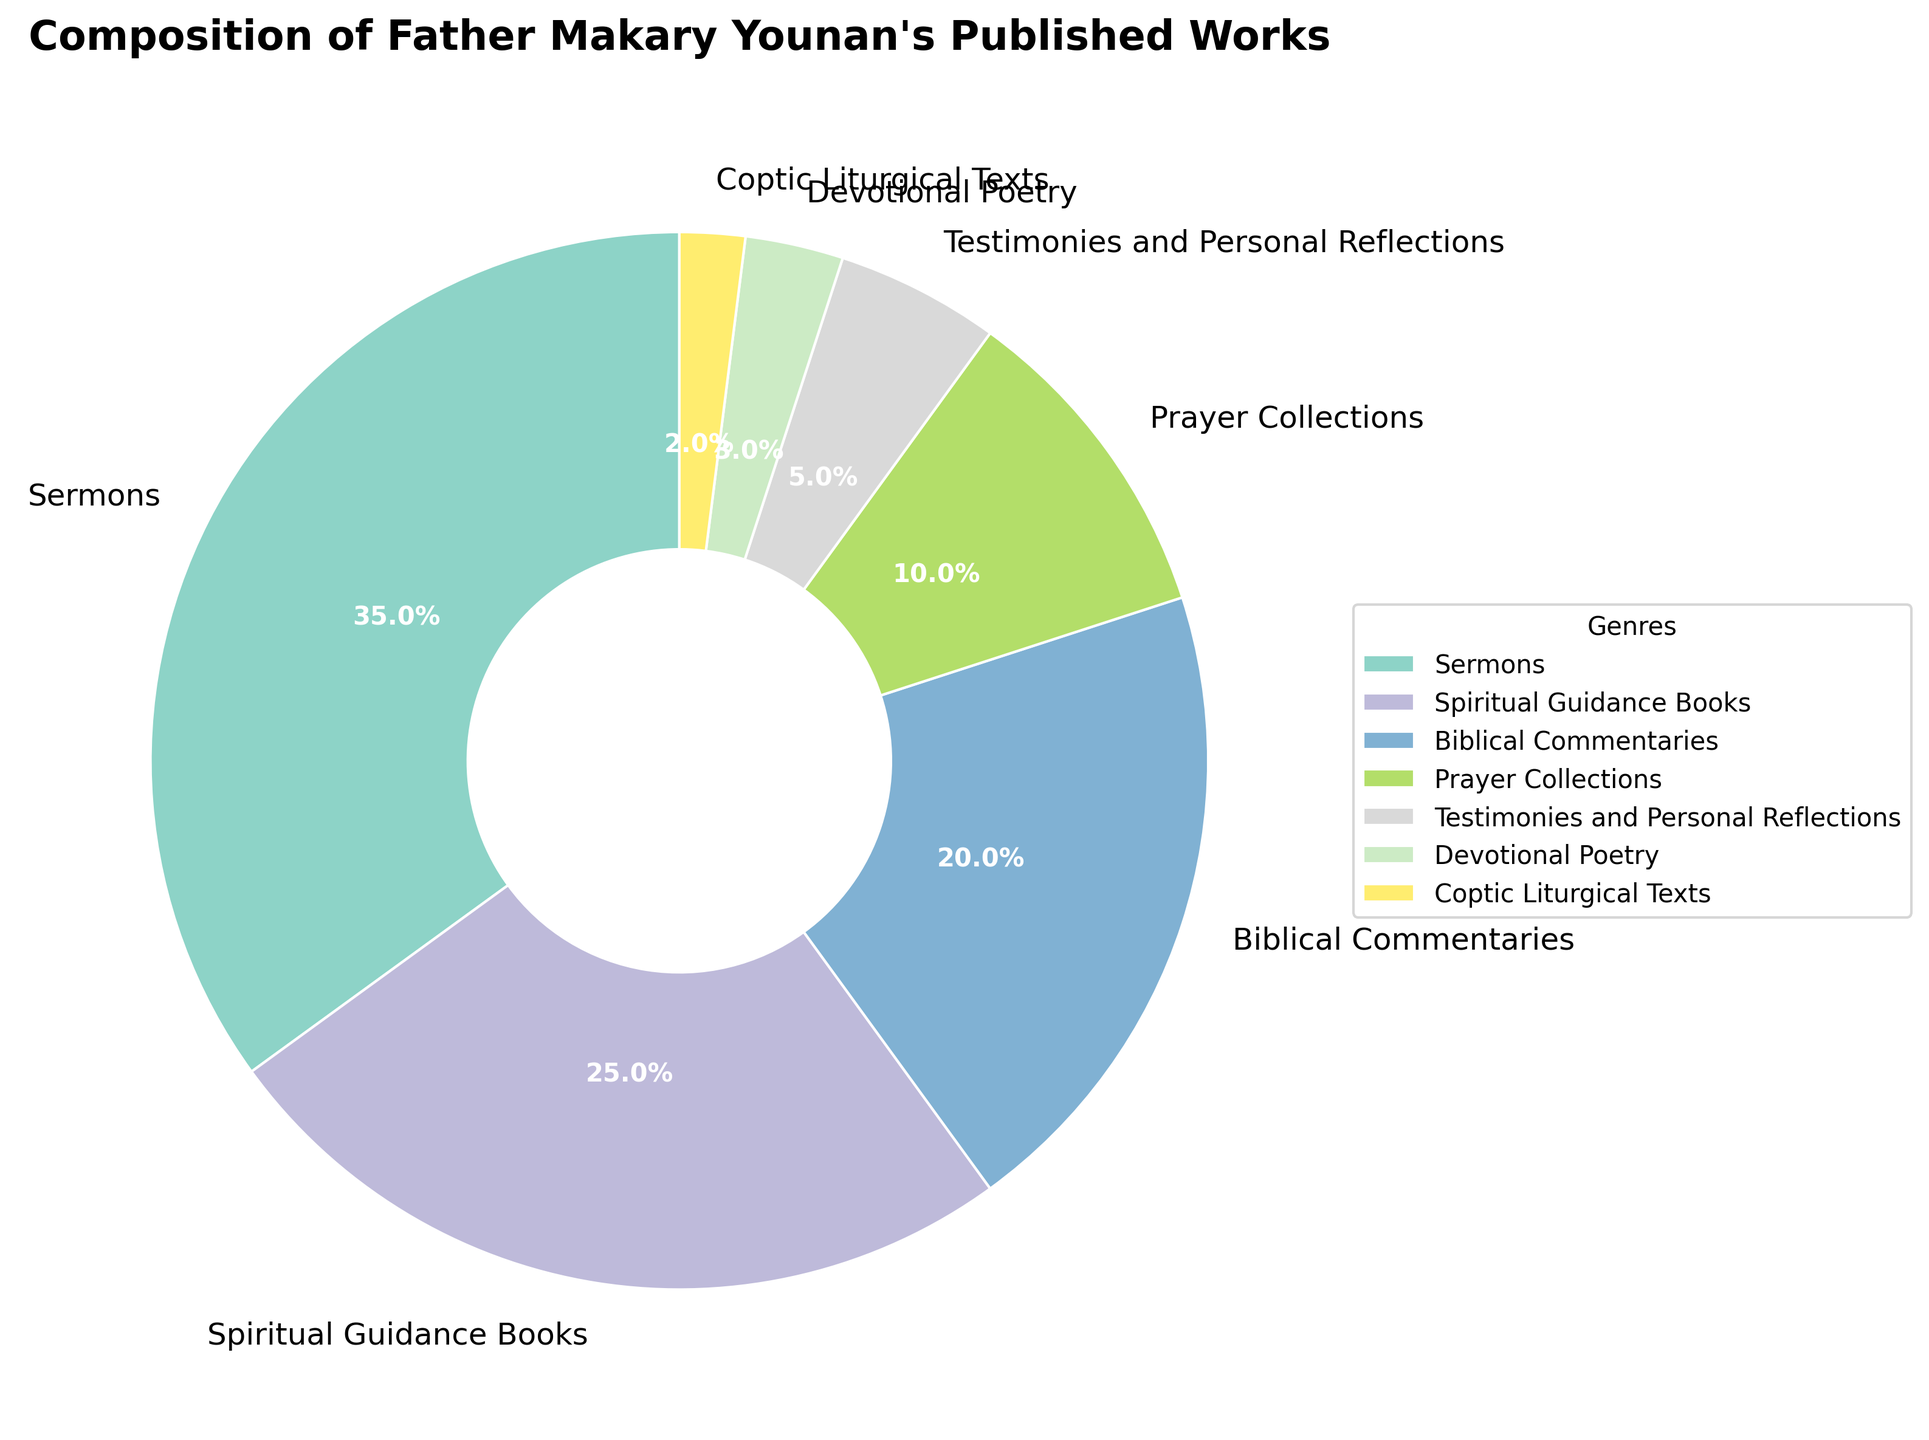What genre represents the largest portion of Father Makary Younan's published works? The figure shows the distribution of genres with labels indicating their percentages. "Sermons" has the highest percentage.
Answer: Sermons How many genres take up less than 10% each of the total published works? By looking at the percentages, "Prayer Collections" (10%), "Testimonies and Personal Reflections" (5%), "Devotional Poetry" (3%), and "Coptic Liturgical Texts" (2%) all fall under this criteria. Count these genres.
Answer: 4 What is the combined percentage of "Spiritual Guidance Books" and "Biblical Commentaries"? "Spiritual Guidance Books" is 25% and "Biblical Commentaries" is 20%. Add these two percentages together.
Answer: 45% Which genre has a smaller percentage: "Devotional Poetry" or "Coptic Liturgical Texts"? Compare the percentages for these two genres. "Devotional Poetry" is 3% and "Coptic Liturgical Texts" is 2%. "Coptic Liturgical Texts" has a smaller percentage.
Answer: Coptic Liturgical Texts What percentage of Father Makary Younan's works are in genres other than "Sermons"? All genres add up to 100%. Subtract the percentage of "Sermons" (35%) from 100%.
Answer: 65% Which genres together make up exactly half (50%) of the published works? Sum the percentages of different genre combinations until the sum reaches 50%. "Spiritual Guidance Books" (25%) + "Biblical Commentaries" (20%) + "Coptic Liturgical Texts" (2%) + "Devotional Poetry" (3%) equals 50%.
Answer: Spiritual Guidance Books, Biblical Commentaries, Coptic Liturgical Texts, Devotional Poetry By how much percentage does "Sermons" exceed the "Prayer Collections"? Subtract the percentage of "Prayer Collections" (10%) from "Sermons" (35%) to find the difference.
Answer: 25% Looking at the visual attributes, which genre is colored with the lightest shade in the figure? Visually identify the lightest shade/color used in the pie chart. The labels indicate the genre associated with each color. The lightest shade is used for "Coptic Liturgical Texts".
Answer: Coptic Liturgical Texts What is the percentage difference between the largest and smallest genre categories? Identify the percentages of the largest ("Sermons" at 35%) and the smallest ("Coptic Liturgical Texts" at 2%). Subtract the smallest percentage from the largest.
Answer: 33% Which genre takes up exactly one-quarter of Father Makary Younan's published works? One-quarter translates to 25%. Check the percentage values on the figure to identify the genre with this value. "Spiritual Guidance Books" is 25%.
Answer: Spiritual Guidance Books 